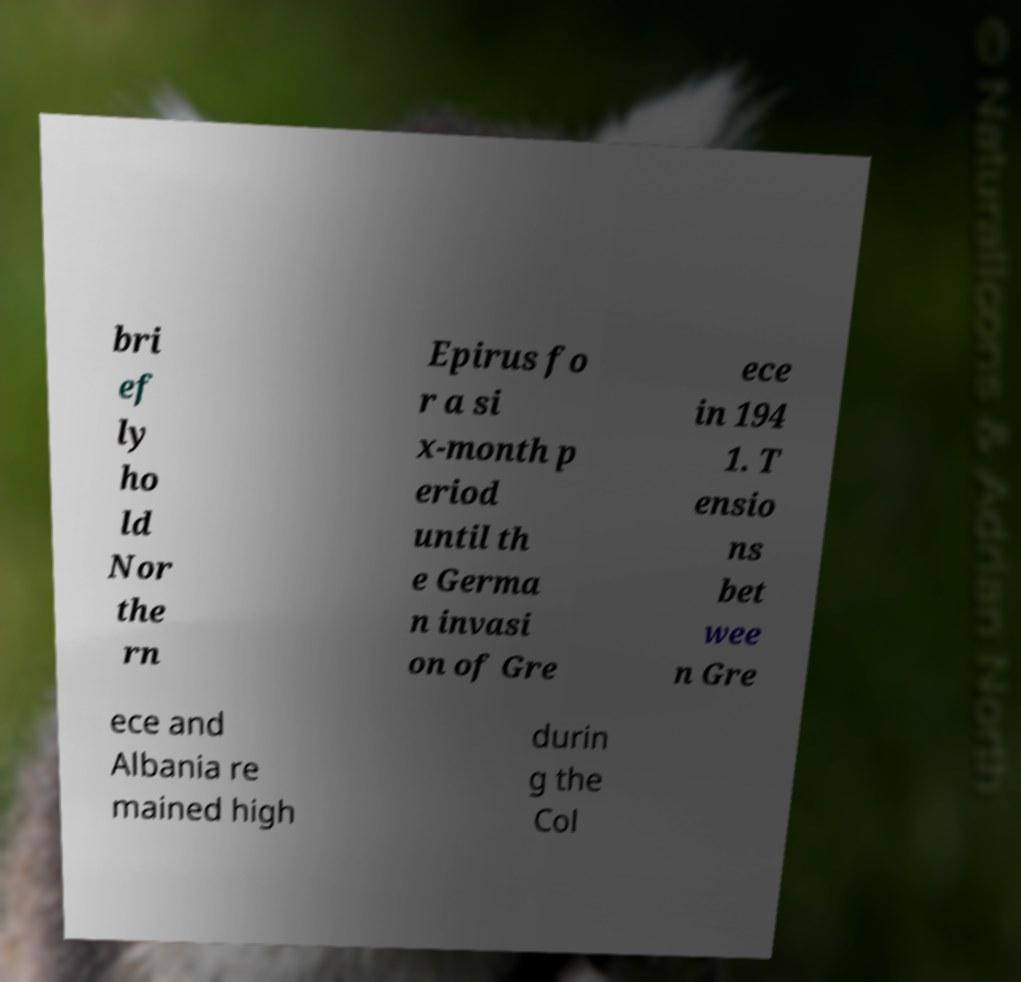Can you read and provide the text displayed in the image?This photo seems to have some interesting text. Can you extract and type it out for me? bri ef ly ho ld Nor the rn Epirus fo r a si x-month p eriod until th e Germa n invasi on of Gre ece in 194 1. T ensio ns bet wee n Gre ece and Albania re mained high durin g the Col 